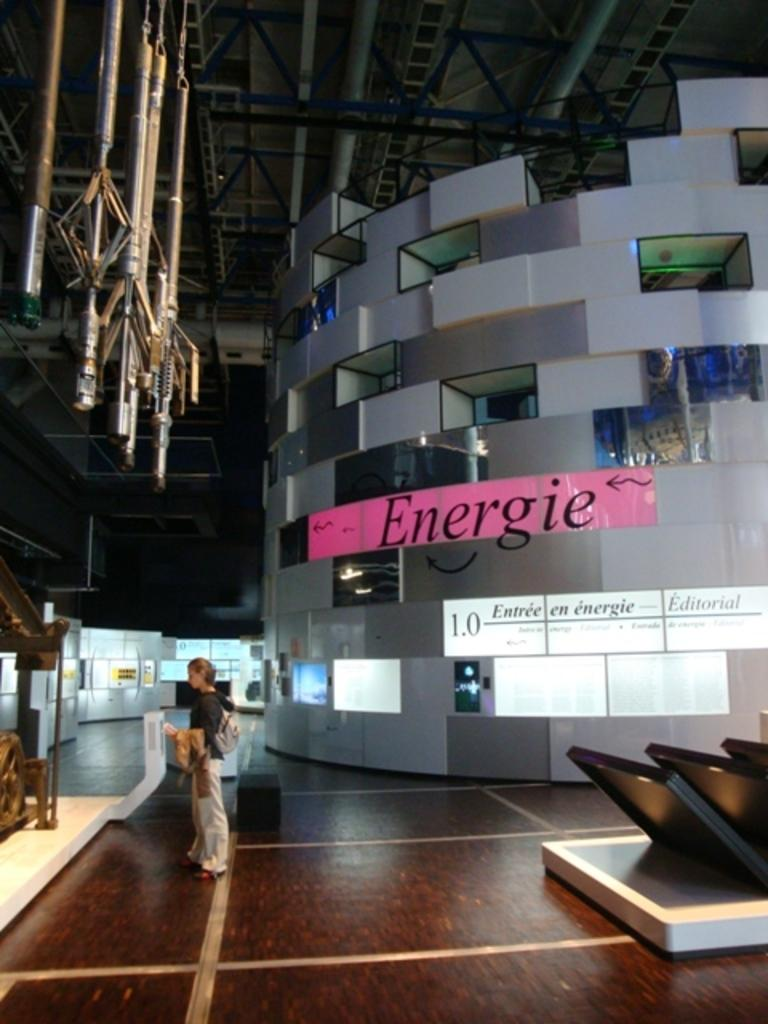Provide a one-sentence caption for the provided image. a place where a man stands and it says Energie in the background. 